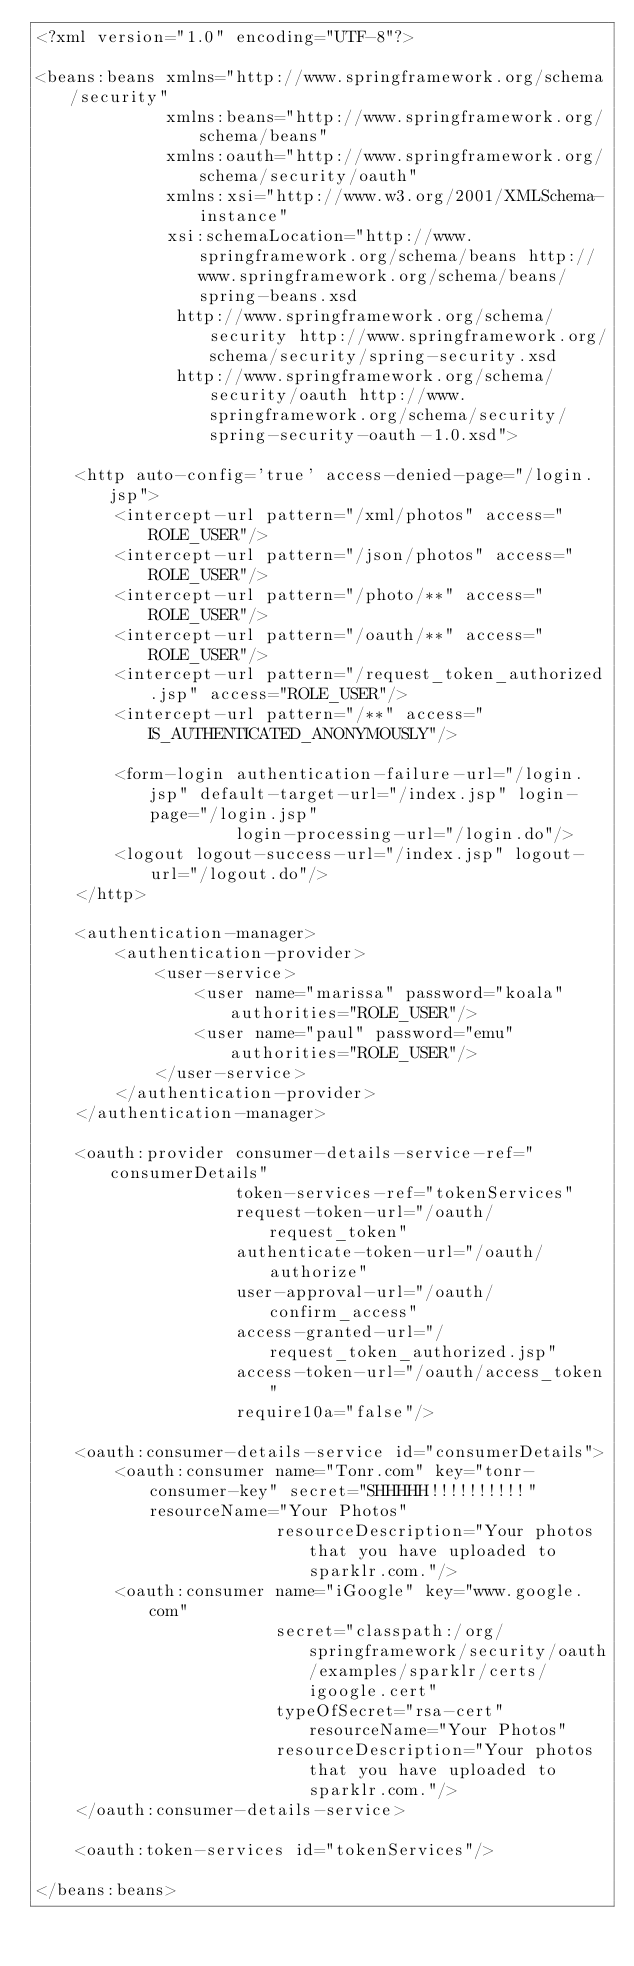<code> <loc_0><loc_0><loc_500><loc_500><_XML_><?xml version="1.0" encoding="UTF-8"?>

<beans:beans xmlns="http://www.springframework.org/schema/security"
             xmlns:beans="http://www.springframework.org/schema/beans"
             xmlns:oauth="http://www.springframework.org/schema/security/oauth"
             xmlns:xsi="http://www.w3.org/2001/XMLSchema-instance"
             xsi:schemaLocation="http://www.springframework.org/schema/beans http://www.springframework.org/schema/beans/spring-beans.xsd
              http://www.springframework.org/schema/security http://www.springframework.org/schema/security/spring-security.xsd
              http://www.springframework.org/schema/security/oauth http://www.springframework.org/schema/security/spring-security-oauth-1.0.xsd">

    <http auto-config='true' access-denied-page="/login.jsp">
        <intercept-url pattern="/xml/photos" access="ROLE_USER"/>
        <intercept-url pattern="/json/photos" access="ROLE_USER"/>
        <intercept-url pattern="/photo/**" access="ROLE_USER"/>
        <intercept-url pattern="/oauth/**" access="ROLE_USER"/>
        <intercept-url pattern="/request_token_authorized.jsp" access="ROLE_USER"/>
        <intercept-url pattern="/**" access="IS_AUTHENTICATED_ANONYMOUSLY"/>

        <form-login authentication-failure-url="/login.jsp" default-target-url="/index.jsp" login-page="/login.jsp"
                    login-processing-url="/login.do"/>
        <logout logout-success-url="/index.jsp" logout-url="/logout.do"/>
    </http>

    <authentication-manager>
        <authentication-provider>
            <user-service>
                <user name="marissa" password="koala" authorities="ROLE_USER"/>
                <user name="paul" password="emu" authorities="ROLE_USER"/>
            </user-service>
        </authentication-provider>
    </authentication-manager>

    <oauth:provider consumer-details-service-ref="consumerDetails"
                    token-services-ref="tokenServices"
                    request-token-url="/oauth/request_token"
                    authenticate-token-url="/oauth/authorize"
                    user-approval-url="/oauth/confirm_access"
                    access-granted-url="/request_token_authorized.jsp"
                    access-token-url="/oauth/access_token"
                    require10a="false"/>

    <oauth:consumer-details-service id="consumerDetails">
        <oauth:consumer name="Tonr.com" key="tonr-consumer-key" secret="SHHHHH!!!!!!!!!!" resourceName="Your Photos"
                        resourceDescription="Your photos that you have uploaded to sparklr.com."/>
        <oauth:consumer name="iGoogle" key="www.google.com"
                        secret="classpath:/org/springframework/security/oauth/examples/sparklr/certs/igoogle.cert"
                        typeOfSecret="rsa-cert" resourceName="Your Photos"
                        resourceDescription="Your photos that you have uploaded to sparklr.com."/>
    </oauth:consumer-details-service>

    <oauth:token-services id="tokenServices"/>

</beans:beans>
</code> 